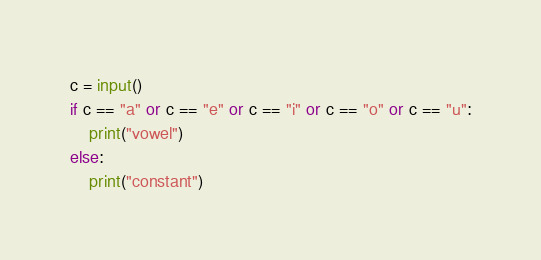<code> <loc_0><loc_0><loc_500><loc_500><_Python_>c = input()
if c == "a" or c == "e" or c == "i" or c == "o" or c == "u":
    print("vowel")
else:
    print("constant")</code> 